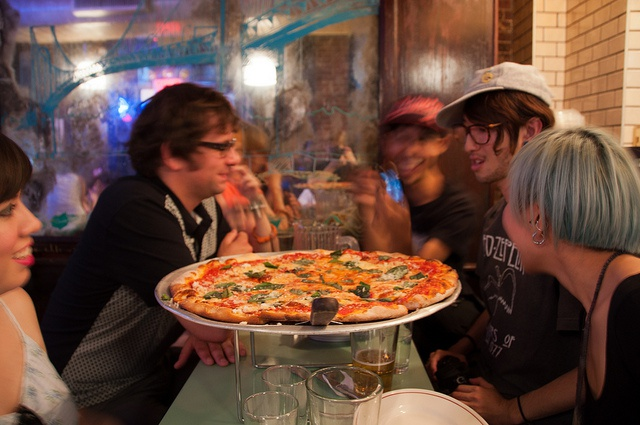Describe the objects in this image and their specific colors. I can see people in black, maroon, brown, and salmon tones, people in black, maroon, tan, and brown tones, people in black, gray, and maroon tones, pizza in black, red, orange, and brown tones, and people in black, maroon, and brown tones in this image. 